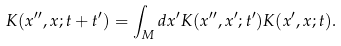Convert formula to latex. <formula><loc_0><loc_0><loc_500><loc_500>K ( x ^ { \prime \prime } , x ; t + t ^ { \prime } ) = \int _ { M } d x ^ { \prime } K ( x ^ { \prime \prime } , x ^ { \prime } ; t ^ { \prime } ) K ( x ^ { \prime } , x ; t ) .</formula> 